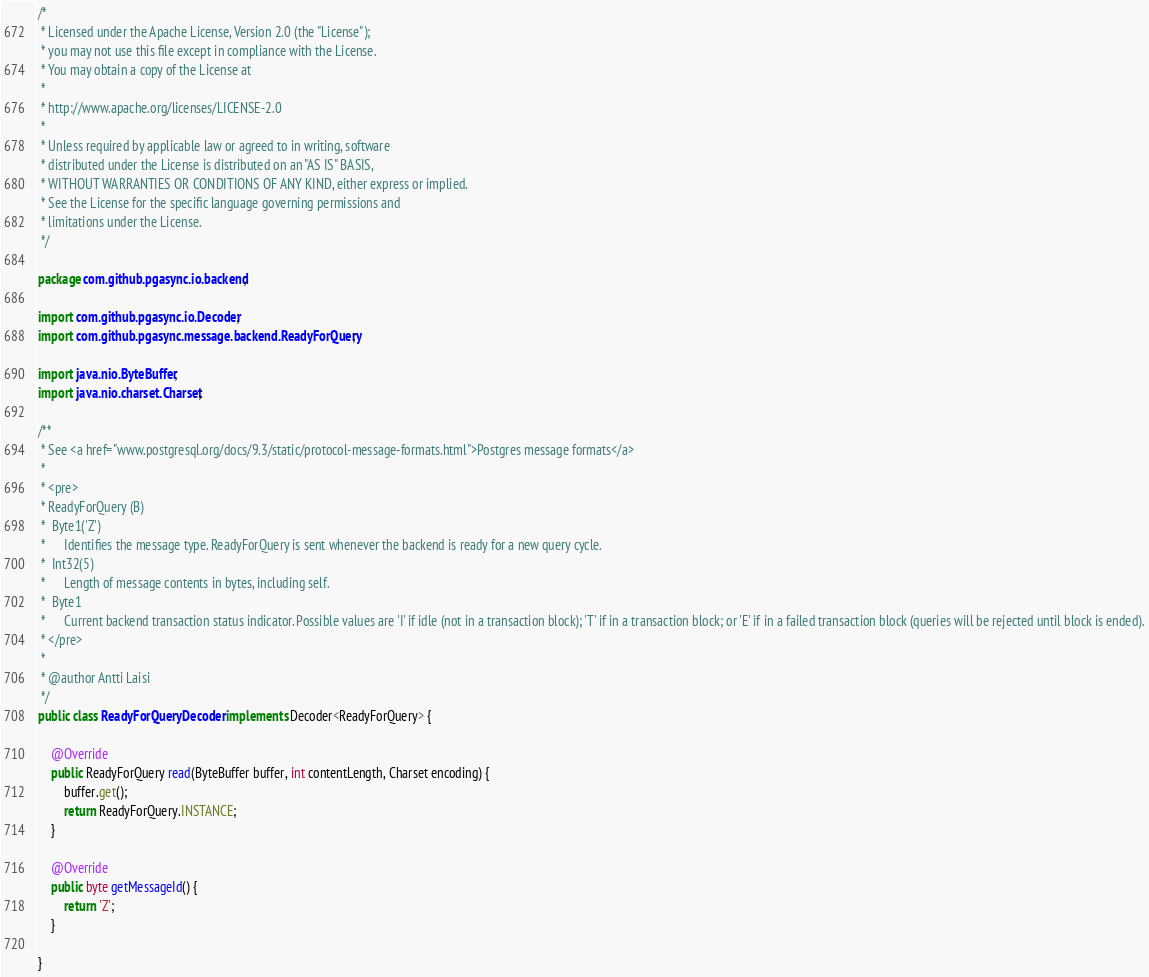<code> <loc_0><loc_0><loc_500><loc_500><_Java_>/*
 * Licensed under the Apache License, Version 2.0 (the "License");
 * you may not use this file except in compliance with the License.
 * You may obtain a copy of the License at
 *
 * http://www.apache.org/licenses/LICENSE-2.0
 *
 * Unless required by applicable law or agreed to in writing, software
 * distributed under the License is distributed on an "AS IS" BASIS,
 * WITHOUT WARRANTIES OR CONDITIONS OF ANY KIND, either express or implied.
 * See the License for the specific language governing permissions and
 * limitations under the License.
 */

package com.github.pgasync.io.backend;

import com.github.pgasync.io.Decoder;
import com.github.pgasync.message.backend.ReadyForQuery;

import java.nio.ByteBuffer;
import java.nio.charset.Charset;

/**
 * See <a href="www.postgresql.org/docs/9.3/static/protocol-message-formats.html">Postgres message formats</a>
 *
 * <pre>
 * ReadyForQuery (B)
 *  Byte1('Z')
 *      Identifies the message type. ReadyForQuery is sent whenever the backend is ready for a new query cycle.
 *  Int32(5)
 *      Length of message contents in bytes, including self.
 *  Byte1
 *      Current backend transaction status indicator. Possible values are 'I' if idle (not in a transaction block); 'T' if in a transaction block; or 'E' if in a failed transaction block (queries will be rejected until block is ended).
 * </pre>
 *
 * @author Antti Laisi
 */
public class ReadyForQueryDecoder implements Decoder<ReadyForQuery> {

    @Override
    public ReadyForQuery read(ByteBuffer buffer, int contentLength, Charset encoding) {
        buffer.get();
        return ReadyForQuery.INSTANCE;
    }

    @Override
    public byte getMessageId() {
        return 'Z';
    }

}
</code> 